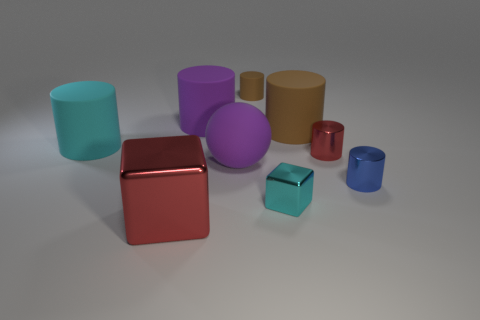What is the size of the cylinder that is the same color as the matte sphere?
Offer a very short reply. Large. Is there a large matte cylinder of the same color as the matte sphere?
Keep it short and to the point. Yes. There is a tiny rubber object; what shape is it?
Keep it short and to the point. Cylinder. Do the cyan cylinder and the rubber ball have the same size?
Ensure brevity in your answer.  Yes. What number of other objects are there of the same shape as the big red object?
Provide a succinct answer. 1. There is a red object on the right side of the purple cylinder; what shape is it?
Offer a very short reply. Cylinder. There is a red shiny thing on the left side of the big purple rubber cylinder; does it have the same shape as the tiny thing in front of the small blue metallic cylinder?
Ensure brevity in your answer.  Yes. Is the number of tiny rubber cylinders that are to the left of the cyan rubber object the same as the number of purple rubber things?
Your answer should be compact. No. There is a cyan thing that is the same shape as the small red object; what is it made of?
Your answer should be compact. Rubber. What shape is the large purple thing behind the cyan thing that is behind the blue cylinder?
Keep it short and to the point. Cylinder. 